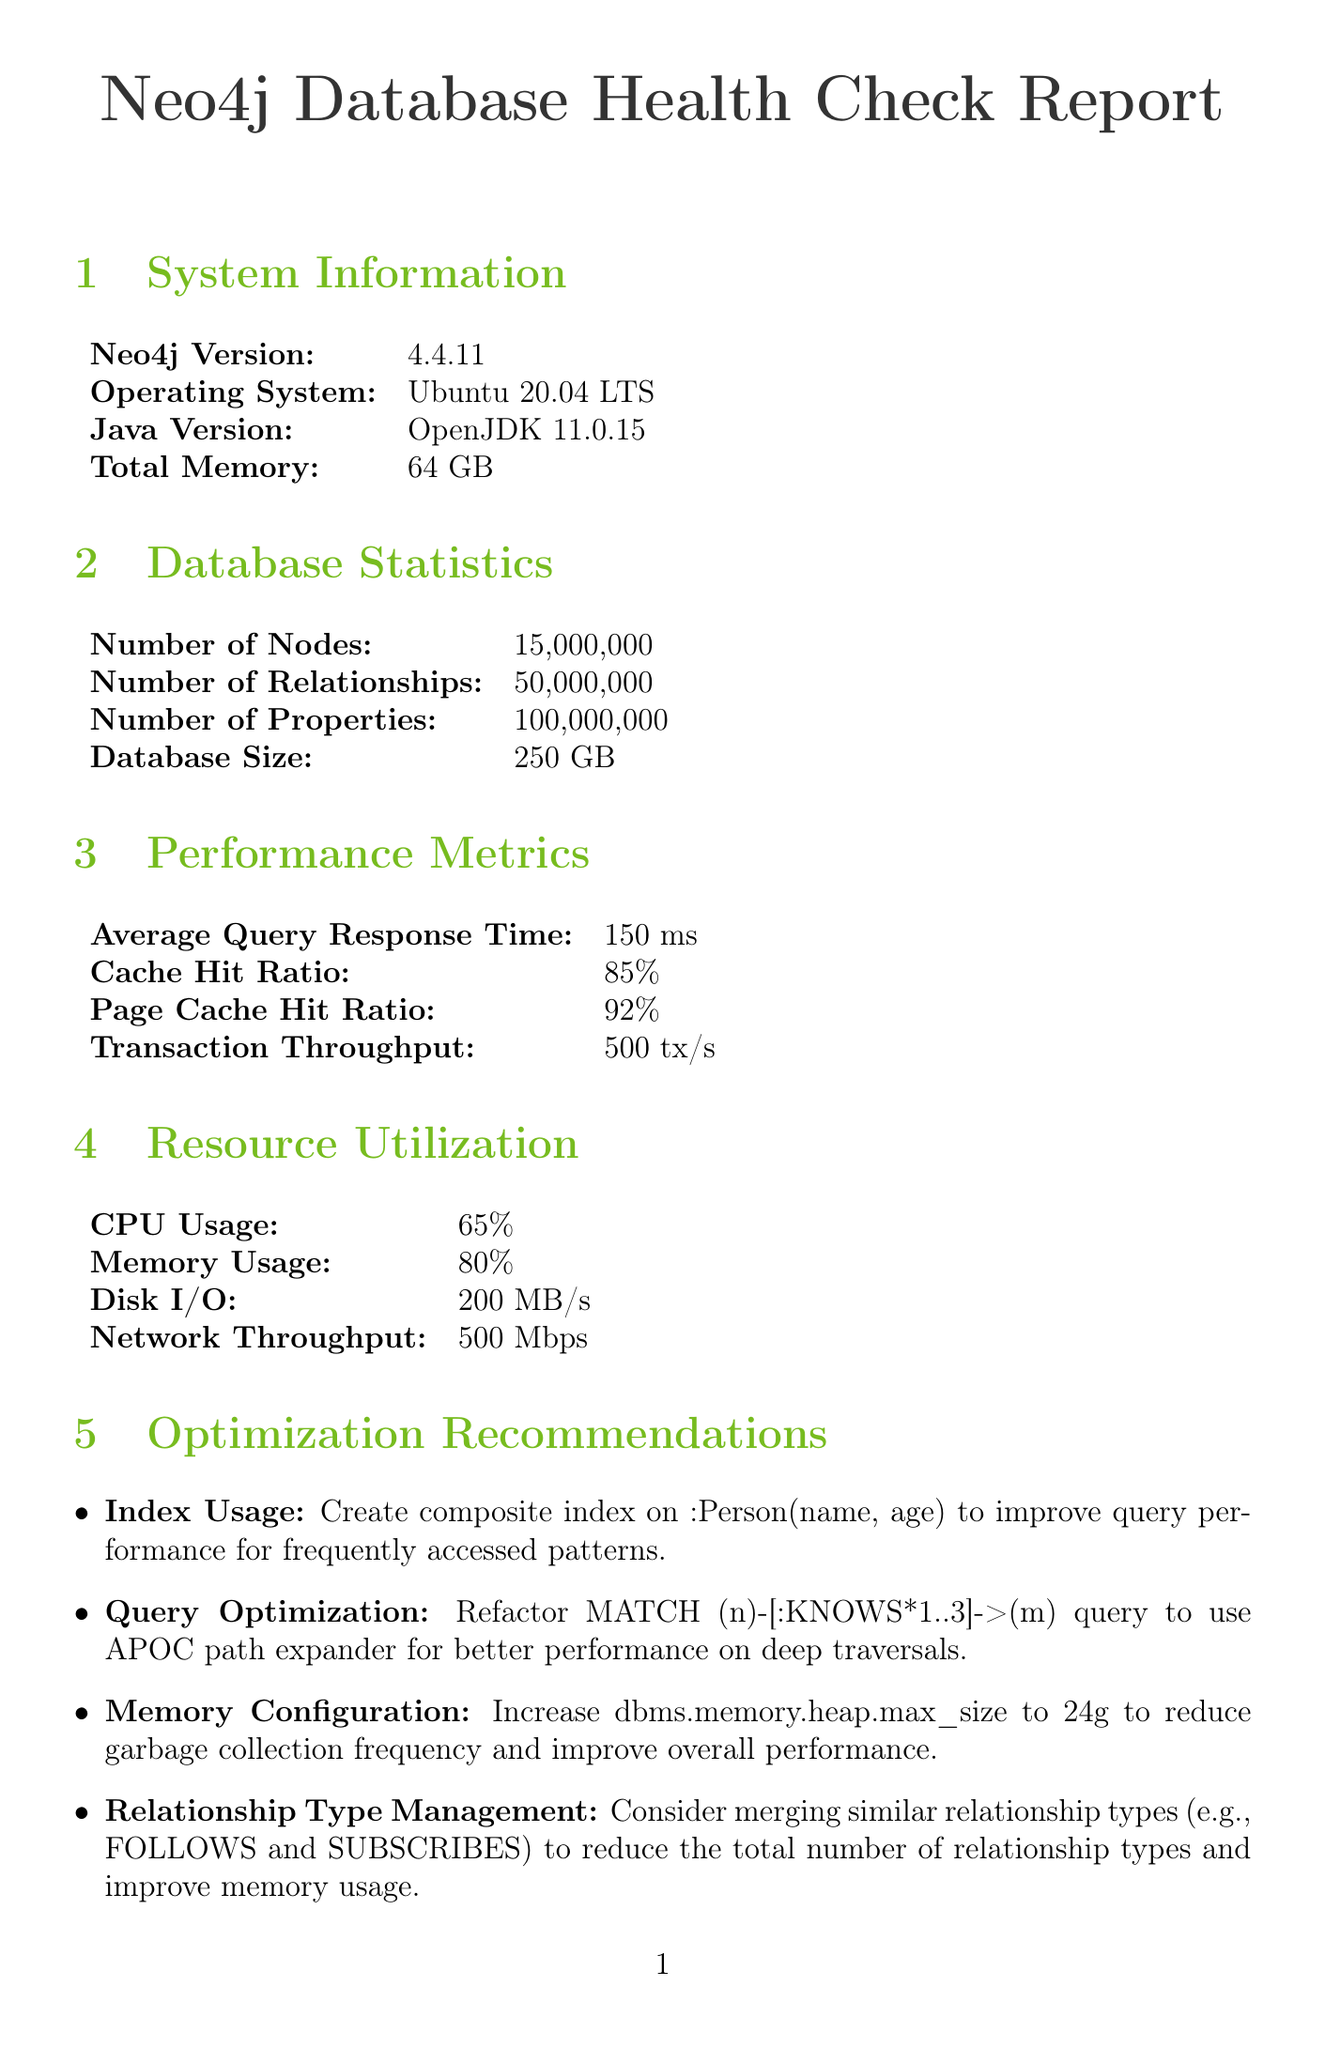What is the Neo4j version? The Neo4j version is specified in the System Information section of the document.
Answer: 4.4.11 What is the maximum heap size recommended for memory configuration? The memory configuration recommendation details the adjustments for the maximum heap size to improve performance.
Answer: 24g What is the cache hit ratio? The cache hit ratio is a performance metric indicating how effective the cache is in serving requests.
Answer: 85 percent When was the last full backup taken? The date of the last full backup is mentioned in the Backup and Recovery section of the document.
Answer: 2023-05-15 What is the transaction throughput? The transaction throughput measures the number of transactions processed per second as indicated in the Performance Metrics section.
Answer: 500 tx/s What is the total memory available to the Neo4j database? The total memory is specified in the System Information section, detailing the hardware resources allocated.
Answer: 64 GB How is the network throughput measured? The network throughput indicates the amount of data transferred over the network and is listed under Resource Utilization.
Answer: 500 Mbps What security feature is enabled for remote access? The Security Assessment section includes recommendations related to securing remote access.
Answer: IP whitelisting What recommendation is provided for index usage? The Optimization Recommendations section outlines improvements related to indexing for performance enhancement.
Answer: Create composite index on :Person(name, age) 